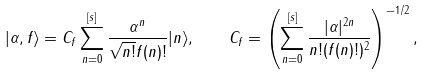Convert formula to latex. <formula><loc_0><loc_0><loc_500><loc_500>| \alpha , f \rangle = C _ { f } \sum _ { n = 0 } ^ { [ s ] } \frac { \alpha ^ { n } } { \sqrt { n ! } f ( n ) ! } | n \rangle , \quad C _ { f } = \left ( \sum _ { n = 0 } ^ { [ s ] } \frac { | \alpha | ^ { 2 n } } { n ! ( f ( n ) ! ) ^ { 2 } } \right ) ^ { - 1 / 2 } ,</formula> 